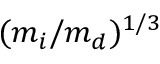<formula> <loc_0><loc_0><loc_500><loc_500>( m _ { i } / m _ { d } ) ^ { 1 / 3 }</formula> 